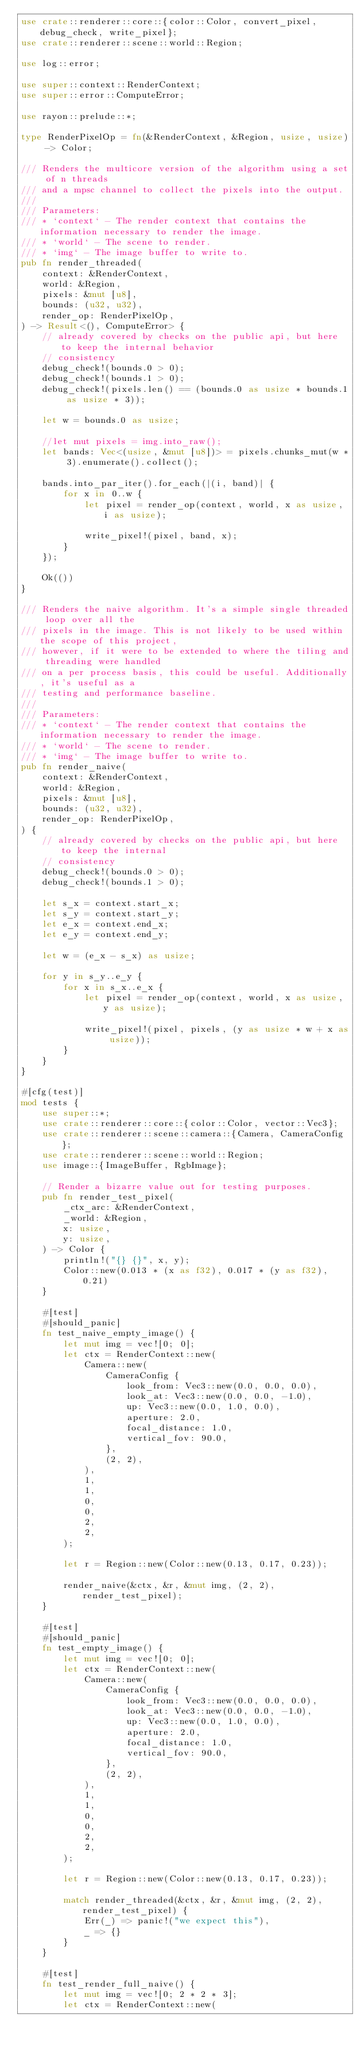Convert code to text. <code><loc_0><loc_0><loc_500><loc_500><_Rust_>use crate::renderer::core::{color::Color, convert_pixel, debug_check, write_pixel};
use crate::renderer::scene::world::Region;

use log::error;

use super::context::RenderContext;
use super::error::ComputeError;

use rayon::prelude::*;

type RenderPixelOp = fn(&RenderContext, &Region, usize, usize) -> Color;

/// Renders the multicore version of the algorithm using a set of n threads
/// and a mpsc channel to collect the pixels into the output.
///
/// Parameters:
/// * `context` - The render context that contains the information necessary to render the image.
/// * `world` - The scene to render.
/// * `img` - The image buffer to write to.
pub fn render_threaded(
    context: &RenderContext,
    world: &Region,
    pixels: &mut [u8],
    bounds: (u32, u32),
    render_op: RenderPixelOp,
) -> Result<(), ComputeError> {
    // already covered by checks on the public api, but here to keep the internal behavior
    // consistency
    debug_check!(bounds.0 > 0);
    debug_check!(bounds.1 > 0);
    debug_check!(pixels.len() == (bounds.0 as usize * bounds.1 as usize * 3));

    let w = bounds.0 as usize;

    //let mut pixels = img.into_raw();
    let bands: Vec<(usize, &mut [u8])> = pixels.chunks_mut(w * 3).enumerate().collect();

    bands.into_par_iter().for_each(|(i, band)| {
        for x in 0..w {
            let pixel = render_op(context, world, x as usize, i as usize);

            write_pixel!(pixel, band, x);
        }
    });

    Ok(())
}

/// Renders the naive algorithm. It's a simple single threaded loop over all the
/// pixels in the image. This is not likely to be used within the scope of this project,
/// however, if it were to be extended to where the tiling and threading were handled
/// on a per process basis, this could be useful. Additionally, it's useful as a
/// testing and performance baseline.
///
/// Parameters:
/// * `context` - The render context that contains the information necessary to render the image.
/// * `world` - The scene to render.
/// * `img` - The image buffer to write to.
pub fn render_naive(
    context: &RenderContext,
    world: &Region,
    pixels: &mut [u8],
    bounds: (u32, u32),
    render_op: RenderPixelOp,
) {
    // already covered by checks on the public api, but here to keep the internal
    // consistency
    debug_check!(bounds.0 > 0);
    debug_check!(bounds.1 > 0);

    let s_x = context.start_x;
    let s_y = context.start_y;
    let e_x = context.end_x;
    let e_y = context.end_y;

    let w = (e_x - s_x) as usize;

    for y in s_y..e_y {
        for x in s_x..e_x {
            let pixel = render_op(context, world, x as usize, y as usize);

            write_pixel!(pixel, pixels, (y as usize * w + x as usize));
        }
    }
}

#[cfg(test)]
mod tests {
    use super::*;
    use crate::renderer::core::{color::Color, vector::Vec3};
    use crate::renderer::scene::camera::{Camera, CameraConfig};
    use crate::renderer::scene::world::Region;
    use image::{ImageBuffer, RgbImage};

    // Render a bizarre value out for testing purposes.
    pub fn render_test_pixel(
        _ctx_arc: &RenderContext,
        _world: &Region,
        x: usize,
        y: usize,
    ) -> Color {
        println!("{} {}", x, y);
        Color::new(0.013 * (x as f32), 0.017 * (y as f32), 0.21)
    }

    #[test]
    #[should_panic]
    fn test_naive_empty_image() {
        let mut img = vec![0; 0];
        let ctx = RenderContext::new(
            Camera::new(
                CameraConfig {
                    look_from: Vec3::new(0.0, 0.0, 0.0),
                    look_at: Vec3::new(0.0, 0.0, -1.0),
                    up: Vec3::new(0.0, 1.0, 0.0),
                    aperture: 2.0,
                    focal_distance: 1.0,
                    vertical_fov: 90.0,
                },
                (2, 2),
            ),
            1,
            1,
            0,
            0,
            2,
            2,
        );

        let r = Region::new(Color::new(0.13, 0.17, 0.23));

        render_naive(&ctx, &r, &mut img, (2, 2), render_test_pixel);
    }

    #[test]
    #[should_panic]
    fn test_empty_image() {
        let mut img = vec![0; 0];
        let ctx = RenderContext::new(
            Camera::new(
                CameraConfig {
                    look_from: Vec3::new(0.0, 0.0, 0.0),
                    look_at: Vec3::new(0.0, 0.0, -1.0),
                    up: Vec3::new(0.0, 1.0, 0.0),
                    aperture: 2.0,
                    focal_distance: 1.0,
                    vertical_fov: 90.0,
                },
                (2, 2),
            ),
            1,
            1,
            0,
            0,
            2,
            2,
        );

        let r = Region::new(Color::new(0.13, 0.17, 0.23));

        match render_threaded(&ctx, &r, &mut img, (2, 2), render_test_pixel) {
            Err(_) => panic!("we expect this"),
            _ => {}
        }
    }

    #[test]
    fn test_render_full_naive() {
        let mut img = vec![0; 2 * 2 * 3];
        let ctx = RenderContext::new(</code> 